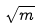<formula> <loc_0><loc_0><loc_500><loc_500>\sqrt { m }</formula> 